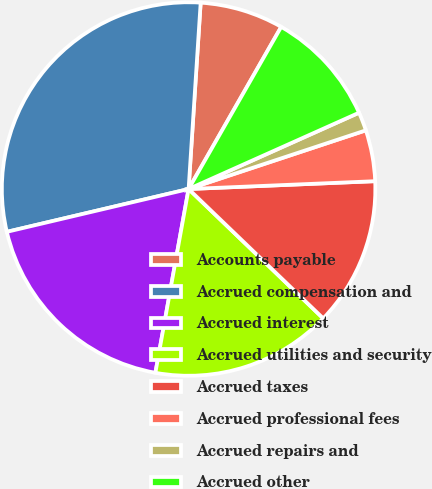<chart> <loc_0><loc_0><loc_500><loc_500><pie_chart><fcel>Accounts payable<fcel>Accrued compensation and<fcel>Accrued interest<fcel>Accrued utilities and security<fcel>Accrued taxes<fcel>Accrued professional fees<fcel>Accrued repairs and<fcel>Accrued other<nl><fcel>7.23%<fcel>29.71%<fcel>18.47%<fcel>15.66%<fcel>12.85%<fcel>4.42%<fcel>1.61%<fcel>10.04%<nl></chart> 